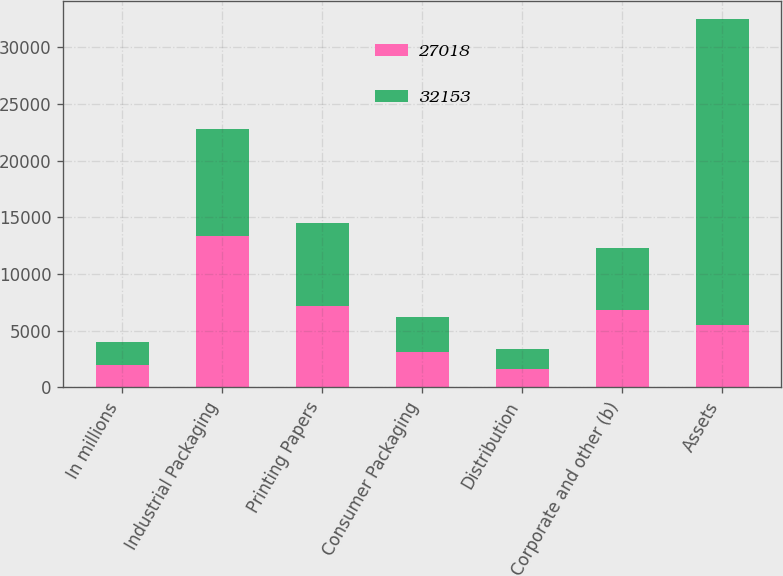Convert chart to OTSL. <chart><loc_0><loc_0><loc_500><loc_500><stacked_bar_chart><ecel><fcel>In millions<fcel>Industrial Packaging<fcel>Printing Papers<fcel>Consumer Packaging<fcel>Distribution<fcel>Corporate and other (b)<fcel>Assets<nl><fcel>27018<fcel>2012<fcel>13353<fcel>7198<fcel>3123<fcel>1639<fcel>6840<fcel>5470<nl><fcel>32153<fcel>2011<fcel>9433<fcel>7311<fcel>3086<fcel>1718<fcel>5470<fcel>27018<nl></chart> 